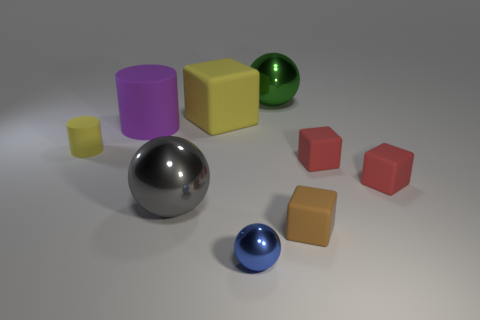There is a cube that is the same color as the tiny cylinder; what size is it?
Give a very brief answer. Large. There is another tiny object that is the same shape as the green object; what color is it?
Your answer should be very brief. Blue. How many large matte cylinders have the same color as the tiny ball?
Give a very brief answer. 0. Is there anything else that is the same shape as the purple matte thing?
Offer a very short reply. Yes. Are there any small brown matte objects that are behind the big metallic sphere that is in front of the metal sphere to the right of the blue metal ball?
Offer a very short reply. No. How many gray spheres are the same material as the small brown thing?
Provide a short and direct response. 0. Do the blue metal thing on the right side of the large purple thing and the matte cube on the left side of the tiny brown object have the same size?
Provide a succinct answer. No. What is the color of the large shiny sphere that is to the right of the large metal ball in front of the ball behind the gray object?
Your response must be concise. Green. Are there any large gray metallic things of the same shape as the large yellow thing?
Provide a succinct answer. No. Are there an equal number of gray metal objects that are behind the yellow matte cube and tiny brown rubber objects that are on the left side of the large gray sphere?
Keep it short and to the point. Yes. 